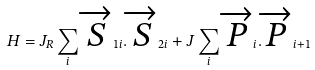Convert formula to latex. <formula><loc_0><loc_0><loc_500><loc_500>H = J _ { R } \sum _ { i } \overrightarrow { S } _ { 1 i } . \overrightarrow { S } _ { 2 i } + J \sum _ { i } \overrightarrow { P } _ { i } . \overrightarrow { P } _ { i + 1 }</formula> 